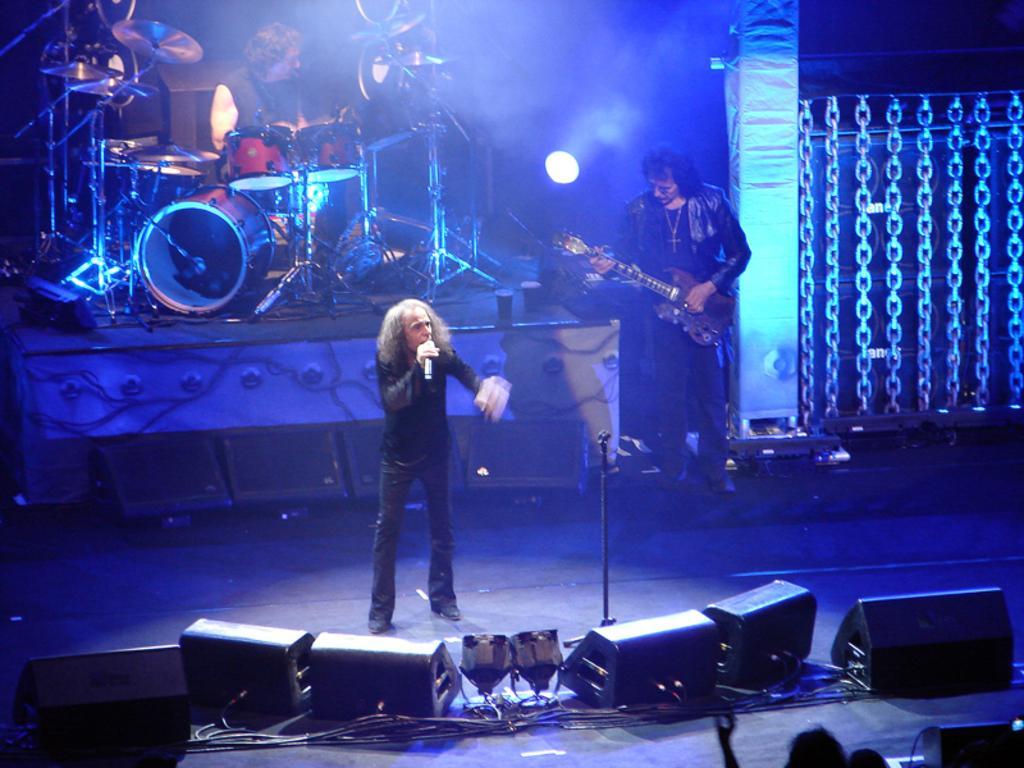Please provide a concise description of this image. In the left middle of the image, I can see a person standing and singing in a mile. In the middle of the image right, I can see a person standing and playing a guitar. In the left top of the image, I can see a person playing musical instruments. At the bottom of the image, I can see speakers kept on the table. At the right top of the image, there is a chain of iron. At the bottom of the image, there are two persons head visible. This picture is taken during night time in the hall. 